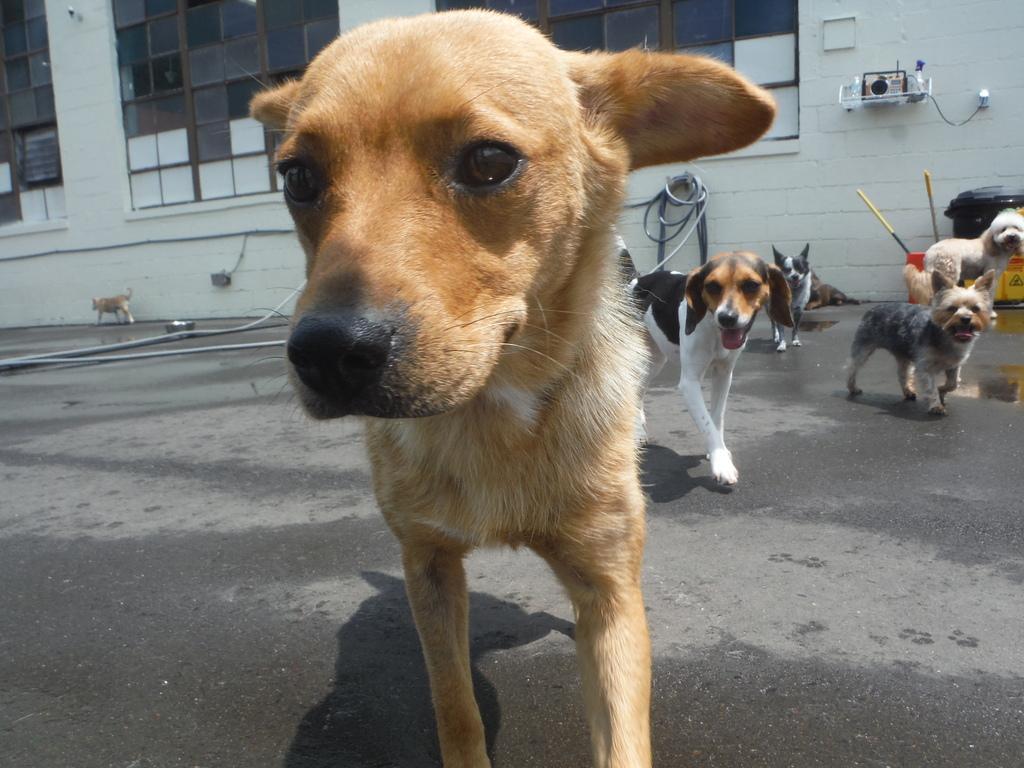Describe this image in one or two sentences. In this image on the ground there are many dogs. In the background there is a building. 